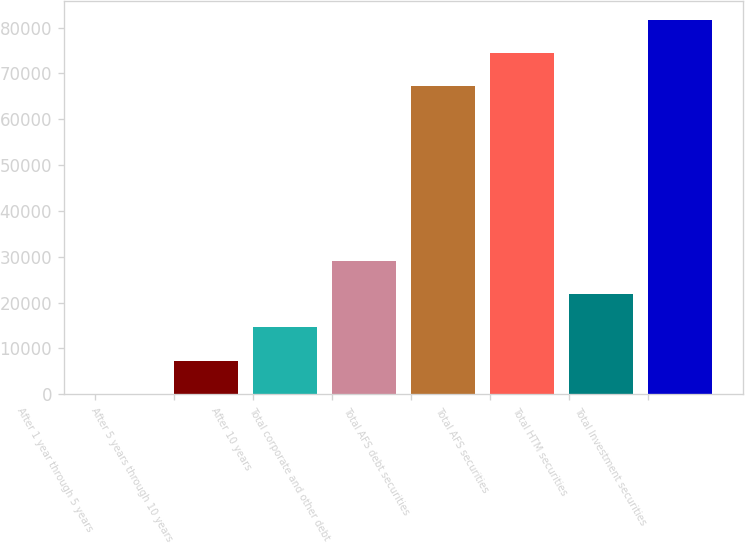<chart> <loc_0><loc_0><loc_500><loc_500><bar_chart><fcel>After 1 year through 5 years<fcel>After 5 years through 10 years<fcel>After 10 years<fcel>Total corporate and other debt<fcel>Total AFS debt securities<fcel>Total AFS securities<fcel>Total HTM securities<fcel>Total Investment securities<nl><fcel>88<fcel>7328.5<fcel>14569<fcel>29050<fcel>67254<fcel>74494.5<fcel>21809.5<fcel>81735<nl></chart> 